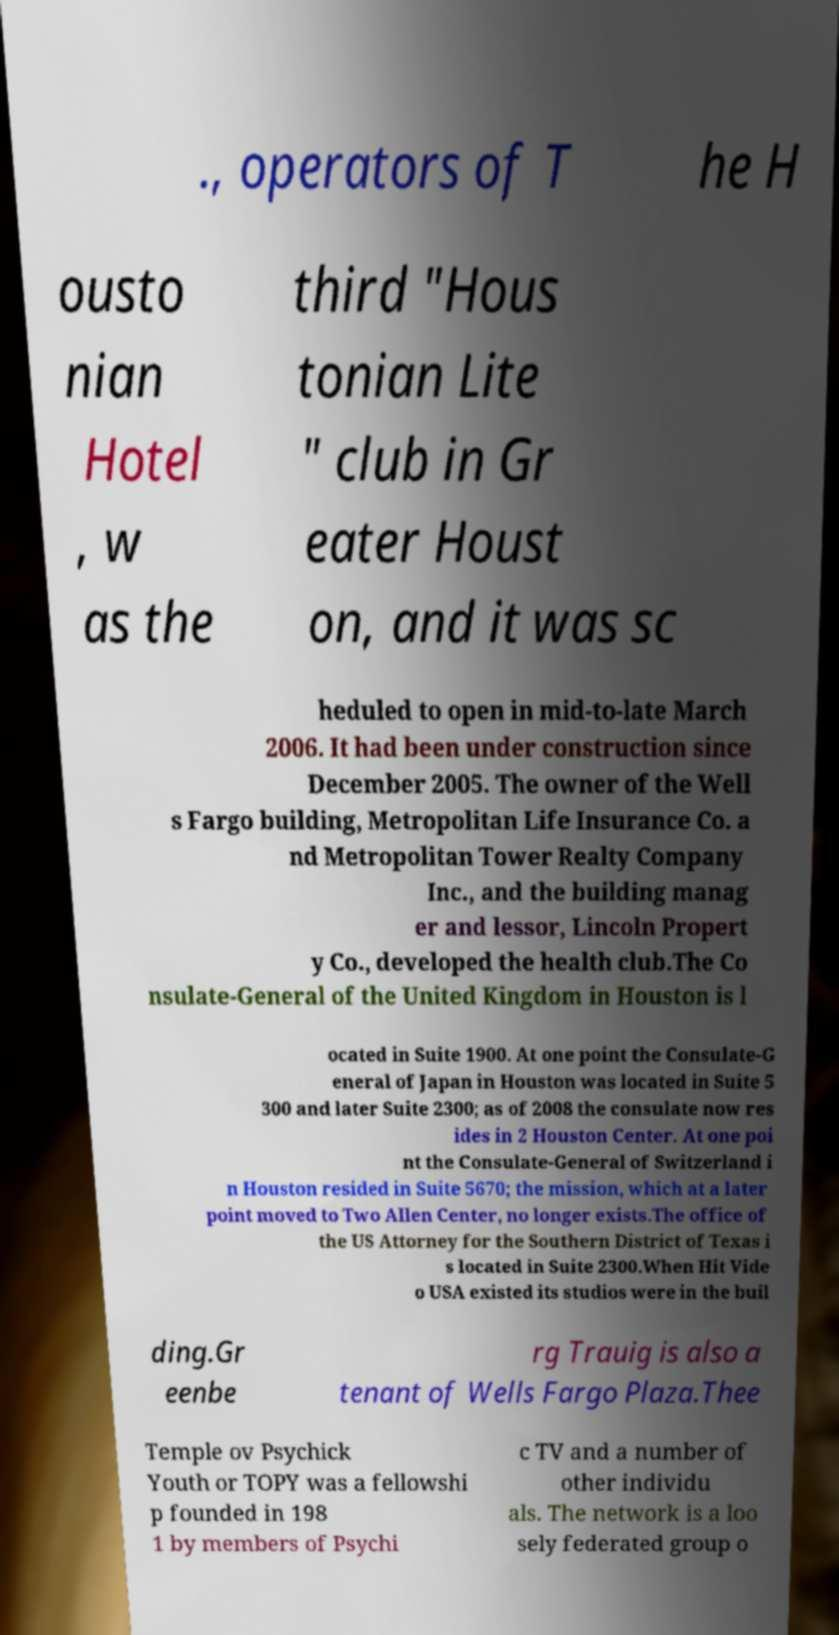Can you read and provide the text displayed in the image?This photo seems to have some interesting text. Can you extract and type it out for me? ., operators of T he H ousto nian Hotel , w as the third "Hous tonian Lite " club in Gr eater Houst on, and it was sc heduled to open in mid-to-late March 2006. It had been under construction since December 2005. The owner of the Well s Fargo building, Metropolitan Life Insurance Co. a nd Metropolitan Tower Realty Company Inc., and the building manag er and lessor, Lincoln Propert y Co., developed the health club.The Co nsulate-General of the United Kingdom in Houston is l ocated in Suite 1900. At one point the Consulate-G eneral of Japan in Houston was located in Suite 5 300 and later Suite 2300; as of 2008 the consulate now res ides in 2 Houston Center. At one poi nt the Consulate-General of Switzerland i n Houston resided in Suite 5670; the mission, which at a later point moved to Two Allen Center, no longer exists.The office of the US Attorney for the Southern District of Texas i s located in Suite 2300.When Hit Vide o USA existed its studios were in the buil ding.Gr eenbe rg Trauig is also a tenant of Wells Fargo Plaza.Thee Temple ov Psychick Youth or TOPY was a fellowshi p founded in 198 1 by members of Psychi c TV and a number of other individu als. The network is a loo sely federated group o 